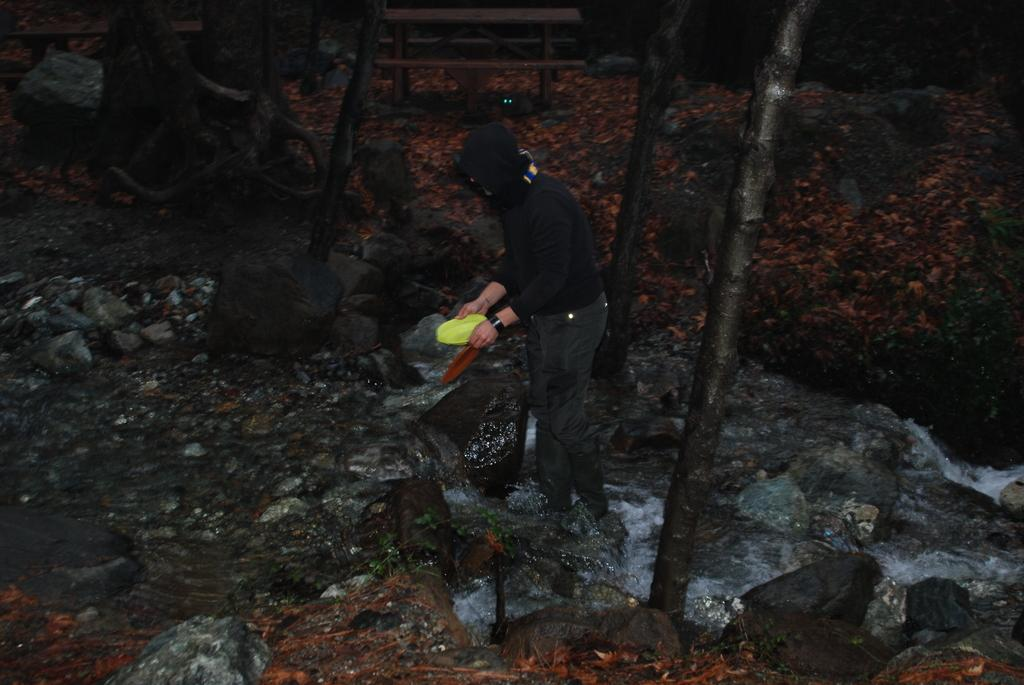What type of terrain is visible in the image? There are rocks on the ground in the image. What natural elements can be seen in the image? There are trees visible in the image. What is happening with the water in the image? Water is flowing in the image. Can you describe the person in the image? There is a man in the image, and he is wearing a cap. What object is the man holding in his hand? The man is holding a plastic bowl in his hand. How many chickens are flying over the man in the image? There are no chickens present in the image. What type of bone is the man using to dig in the ground? There is no bone visible in the image, and the man is not digging in the ground. 